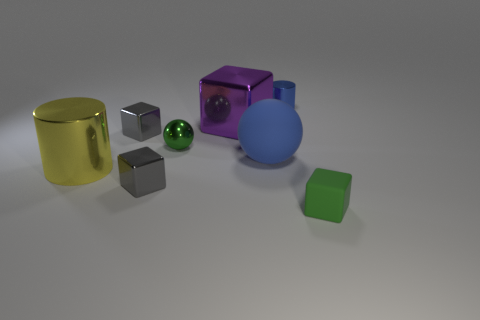Are there the same number of metallic cylinders that are in front of the large yellow cylinder and green metal cylinders?
Offer a very short reply. Yes. How many other things are there of the same size as the purple cube?
Offer a very short reply. 2. Do the green object that is behind the yellow metal cylinder and the large purple thing that is behind the green block have the same material?
Ensure brevity in your answer.  Yes. There is a blue thing in front of the green object behind the green rubber thing; what size is it?
Ensure brevity in your answer.  Large. Are there any metal objects that have the same color as the tiny sphere?
Offer a very short reply. No. There is a matte object in front of the blue rubber object; is its color the same as the big cube to the left of the blue metallic thing?
Provide a succinct answer. No. The blue rubber object is what shape?
Give a very brief answer. Sphere. There is a green rubber block; what number of tiny blocks are to the left of it?
Provide a succinct answer. 2. How many green things have the same material as the big blue ball?
Offer a terse response. 1. Is the tiny gray cube in front of the big yellow cylinder made of the same material as the blue sphere?
Your answer should be very brief. No. 